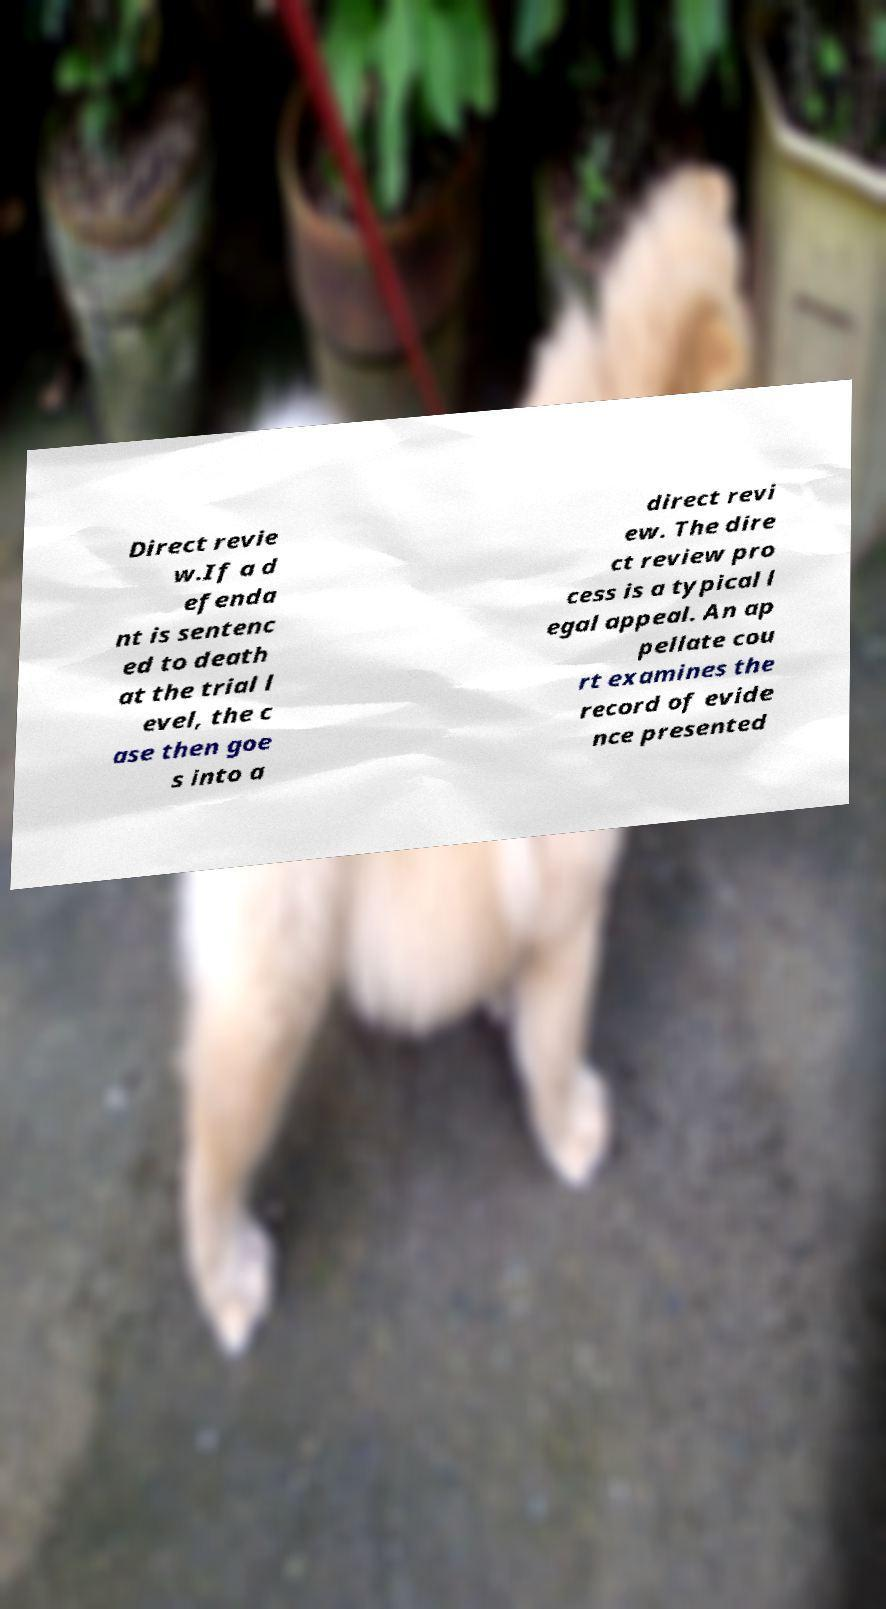Please identify and transcribe the text found in this image. Direct revie w.If a d efenda nt is sentenc ed to death at the trial l evel, the c ase then goe s into a direct revi ew. The dire ct review pro cess is a typical l egal appeal. An ap pellate cou rt examines the record of evide nce presented 